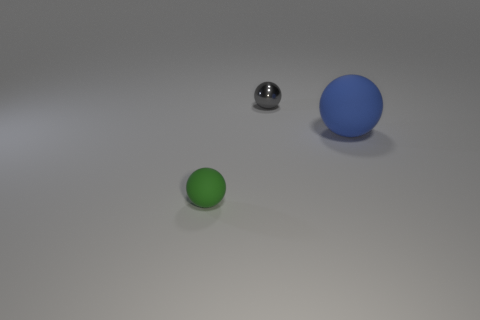Are there any other things that are made of the same material as the gray thing?
Offer a terse response. No. Is there anything else that is the same size as the blue sphere?
Your response must be concise. No. What color is the tiny sphere behind the tiny thing in front of the rubber thing behind the small rubber thing?
Provide a succinct answer. Gray. There is a tiny thing that is in front of the gray object; are there any green things to the right of it?
Provide a short and direct response. No. Is the shape of the small gray metal object that is on the right side of the small green rubber object the same as  the tiny green object?
Your answer should be very brief. Yes. Are there any other things that have the same shape as the blue object?
Your answer should be very brief. Yes. How many balls are either large blue objects or gray objects?
Give a very brief answer. 2. How many green balls are there?
Ensure brevity in your answer.  1. There is a ball behind the rubber object that is to the right of the green rubber sphere; what is its size?
Offer a very short reply. Small. How many other things are the same size as the blue sphere?
Keep it short and to the point. 0. 